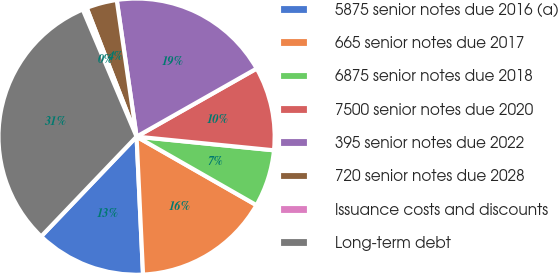Convert chart. <chart><loc_0><loc_0><loc_500><loc_500><pie_chart><fcel>5875 senior notes due 2016 (a)<fcel>665 senior notes due 2017<fcel>6875 senior notes due 2018<fcel>7500 senior notes due 2020<fcel>395 senior notes due 2022<fcel>720 senior notes due 2028<fcel>Issuance costs and discounts<fcel>Long-term debt<nl><fcel>12.89%<fcel>15.99%<fcel>6.69%<fcel>9.79%<fcel>19.09%<fcel>3.59%<fcel>0.49%<fcel>31.49%<nl></chart> 